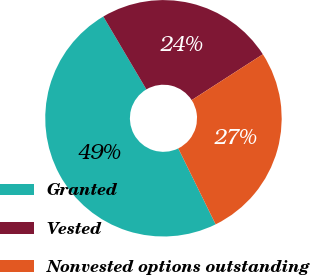Convert chart. <chart><loc_0><loc_0><loc_500><loc_500><pie_chart><fcel>Granted<fcel>Vested<fcel>Nonvested options outstanding<nl><fcel>48.78%<fcel>24.39%<fcel>26.83%<nl></chart> 